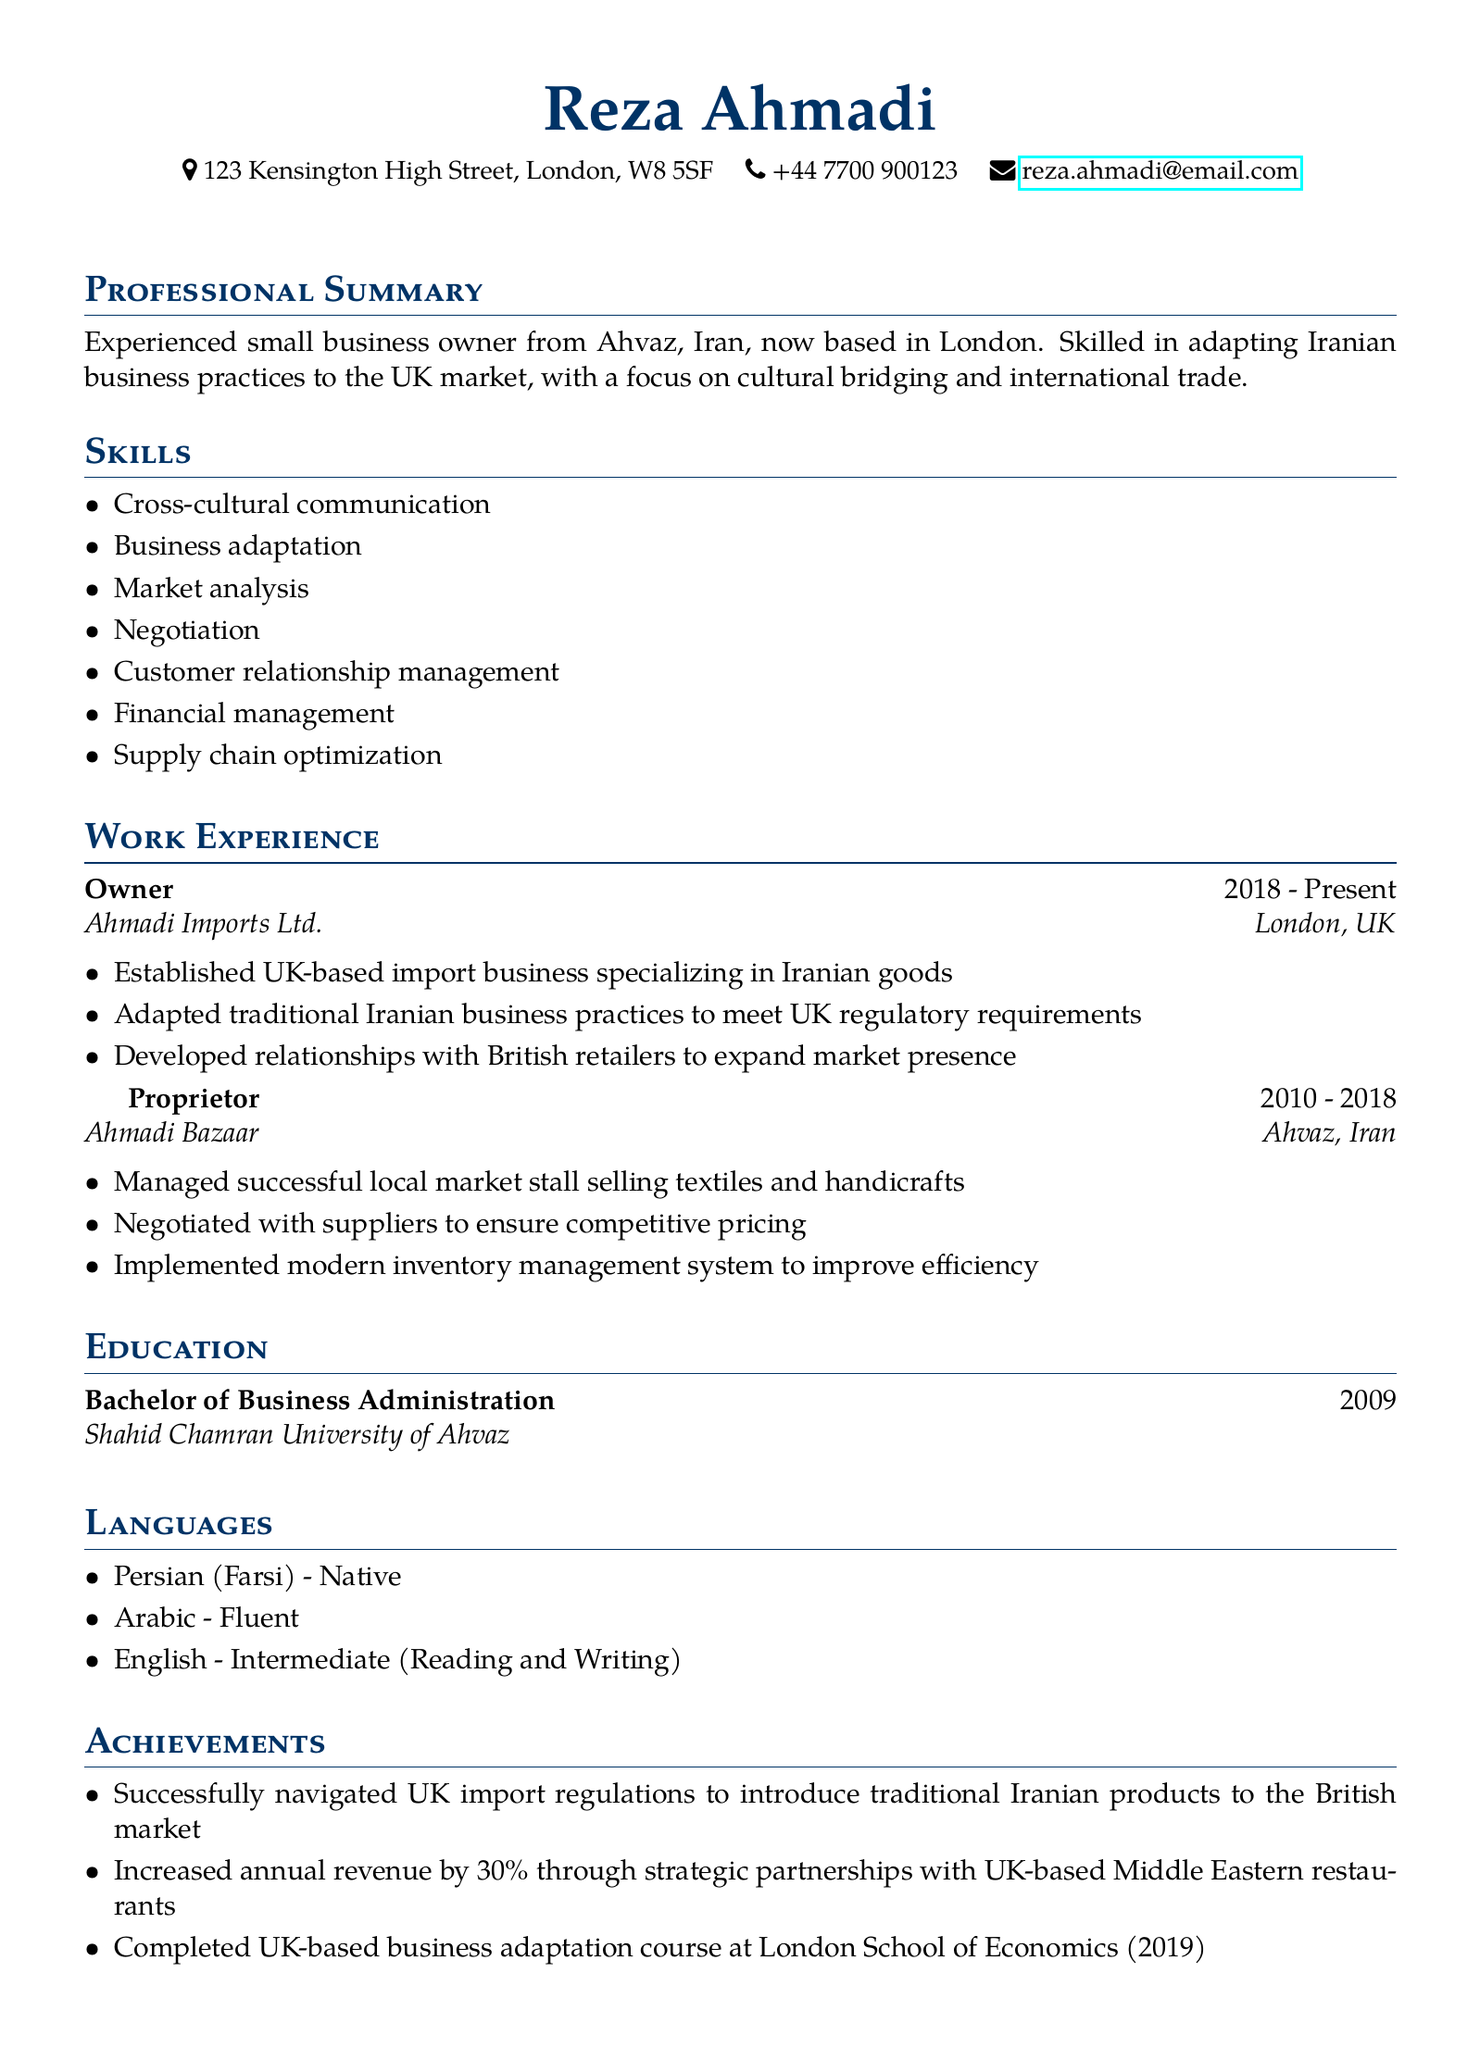what is the name of the individual? The name of the individual is stated prominently at the top of the document.
Answer: Reza Ahmadi what is the email address provided in the document? The email address is given in the contact information section.
Answer: reza.ahmadi@email.com what degree did Reza earn? The document specifies the degree attained and the institution where it was completed.
Answer: Bachelor of Business Administration how long did Reza run Ahmadi Bazaar? The duration of Reza's experience as a proprietor at Ahmadi Bazaar is mentioned in the work experience section.
Answer: 2010 - 2018 what was the percentage increase in annual revenue? The achievement section provides the exact percentage increase in revenue.
Answer: 30% which language is listed as native? The languages section indicates the proficiency levels of various languages.
Answer: Persian (Farsi) what type of business does Ahmadi Imports Ltd. specialize in? The type of business is described under the responsibilities for the Owner position.
Answer: Iranian goods what was completed in 2019? The achievements section outlines significant accomplishments, one of which was completed in 2019.
Answer: UK-based business adaptation course who managed a successful local market stall? The work experience section clearly identifies the role of Reza in managing the market stall.
Answer: Reza Ahmadi 